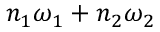<formula> <loc_0><loc_0><loc_500><loc_500>n _ { 1 } \omega _ { 1 } + n _ { 2 } \omega _ { 2 }</formula> 